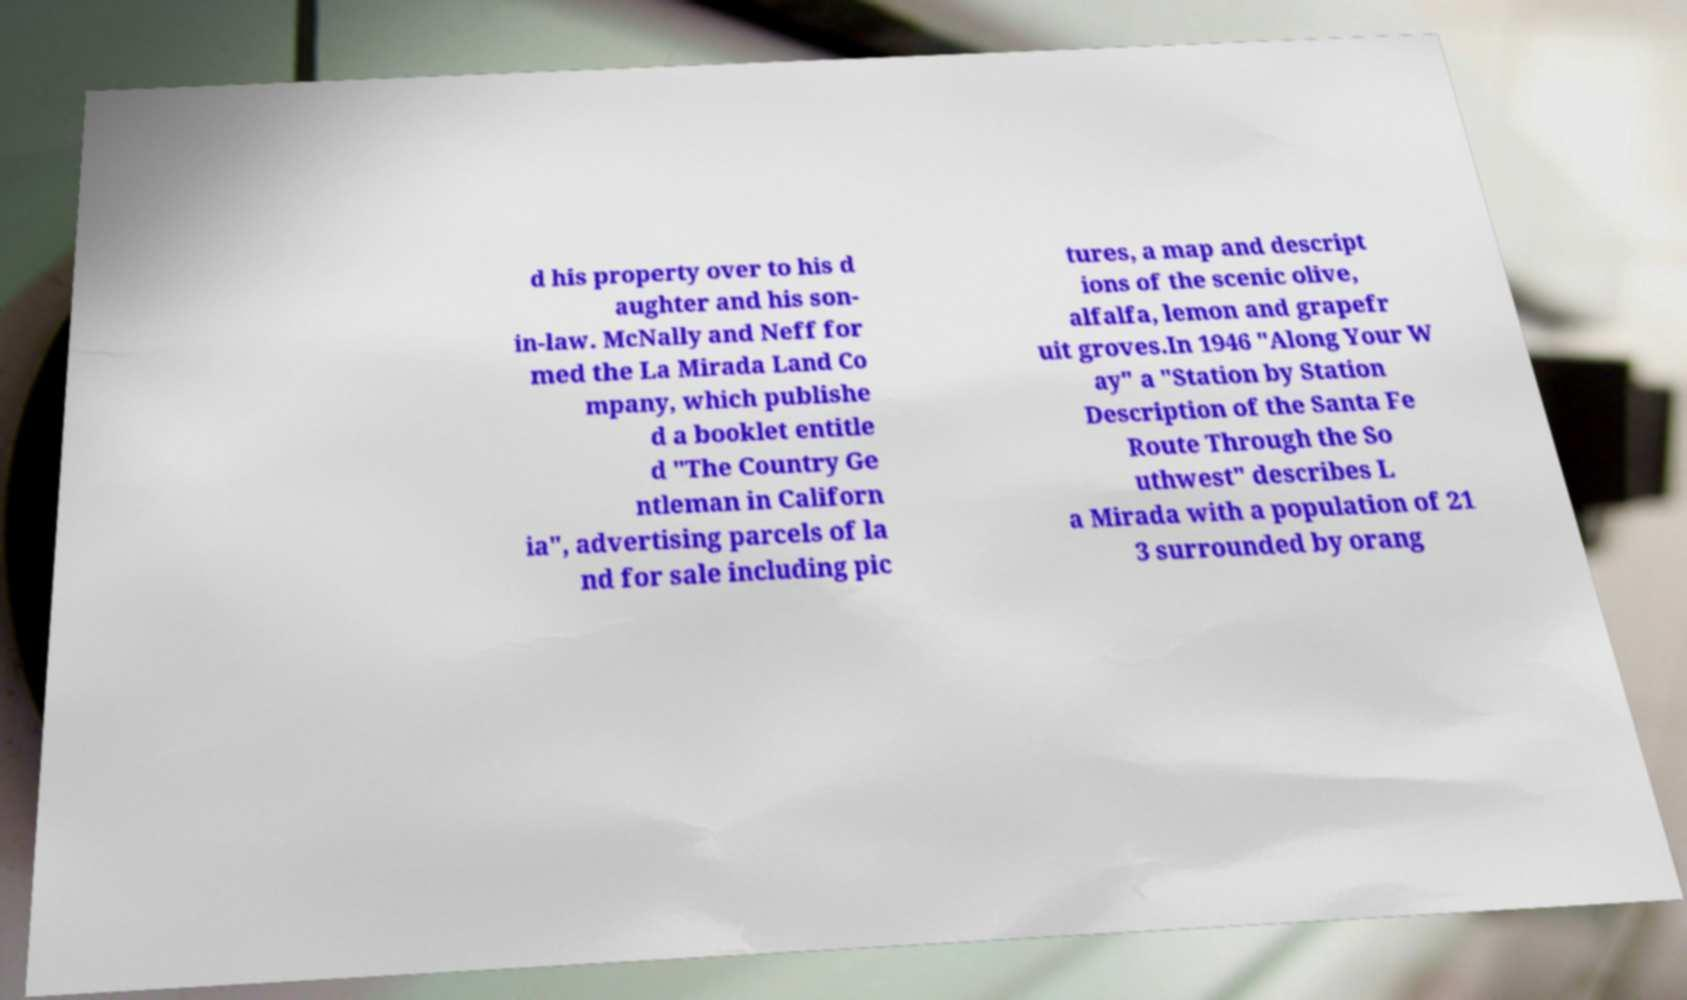What messages or text are displayed in this image? I need them in a readable, typed format. d his property over to his d aughter and his son- in-law. McNally and Neff for med the La Mirada Land Co mpany, which publishe d a booklet entitle d "The Country Ge ntleman in Californ ia", advertising parcels of la nd for sale including pic tures, a map and descript ions of the scenic olive, alfalfa, lemon and grapefr uit groves.In 1946 "Along Your W ay" a "Station by Station Description of the Santa Fe Route Through the So uthwest" describes L a Mirada with a population of 21 3 surrounded by orang 